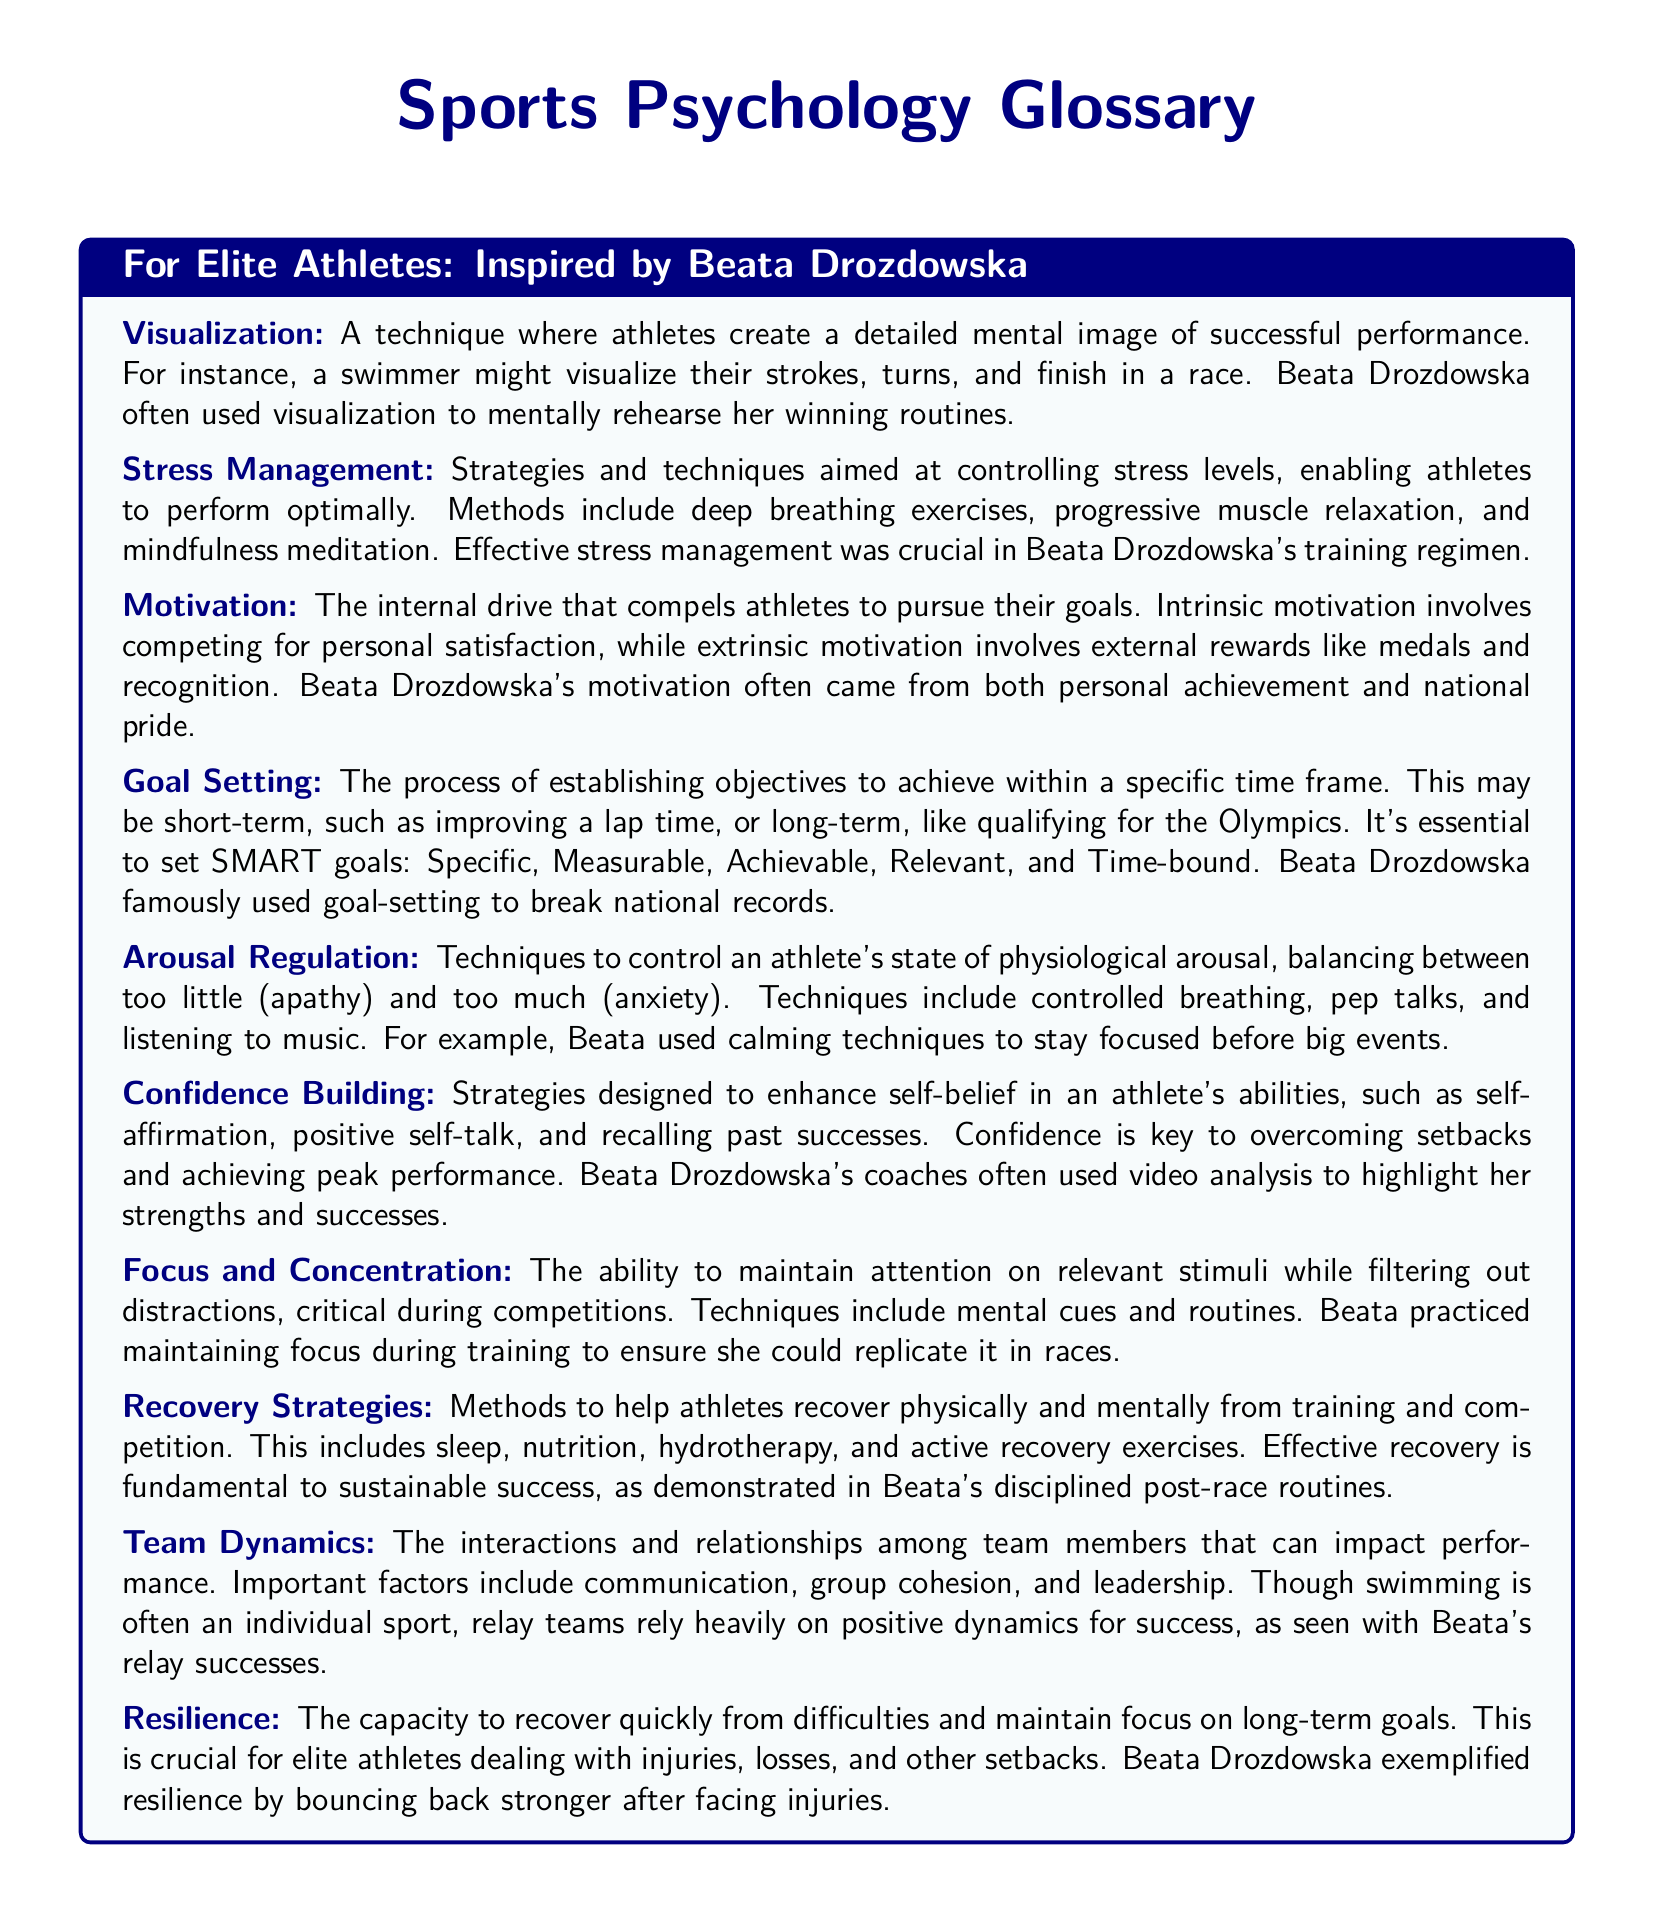what technique did Beata Drozdowska often use for mental rehearsal? The document states that Beata Drozdowska often used visualization to mentally rehearse her winning routines.
Answer: visualization what are the short-term and long-term goals in sports psychology? The document explains that short-term goals may include improving a lap time, while long-term goals could be qualifying for the Olympics.
Answer: improving a lap time; qualifying for the Olympics which strategy helps athletes control their stress levels? The document mentions that strategies for controlling stress levels include deep breathing exercises, progressive muscle relaxation, and mindfulness meditation.
Answer: deep breathing exercises what is a key aspect of team dynamics in sports? The document identifies communication, group cohesion, and leadership as important factors in team dynamics that impact performance.
Answer: communication how does Beata Drozdowska exemplify resilience? The document notes that Beata Drozdowska exemplified resilience by bouncing back stronger after facing injuries.
Answer: bouncing back stronger after facing injuries what does the acronym SMART in goal setting stand for? The document describes that SMART goals are Specific, Measurable, Achievable, Relevant, and Time-bound.
Answer: Specific, Measurable, Achievable, Relevant, Time-bound which technique is used to enhance self-belief in athletes? The document lists self-affirmation, positive self-talk, and recalling past successes as strategies for confidence building.
Answer: positive self-talk what strategy is crucial for athletes during competitions? The document states that focus and concentration are critical for maintaining attention on relevant stimuli during competitions.
Answer: focus and concentration 